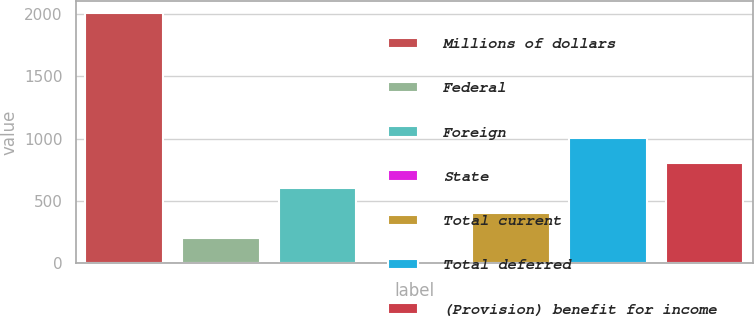<chart> <loc_0><loc_0><loc_500><loc_500><bar_chart><fcel>Millions of dollars<fcel>Federal<fcel>Foreign<fcel>State<fcel>Total current<fcel>Total deferred<fcel>(Provision) benefit for income<nl><fcel>2005<fcel>201.4<fcel>602.2<fcel>1<fcel>401.8<fcel>1003<fcel>802.6<nl></chart> 